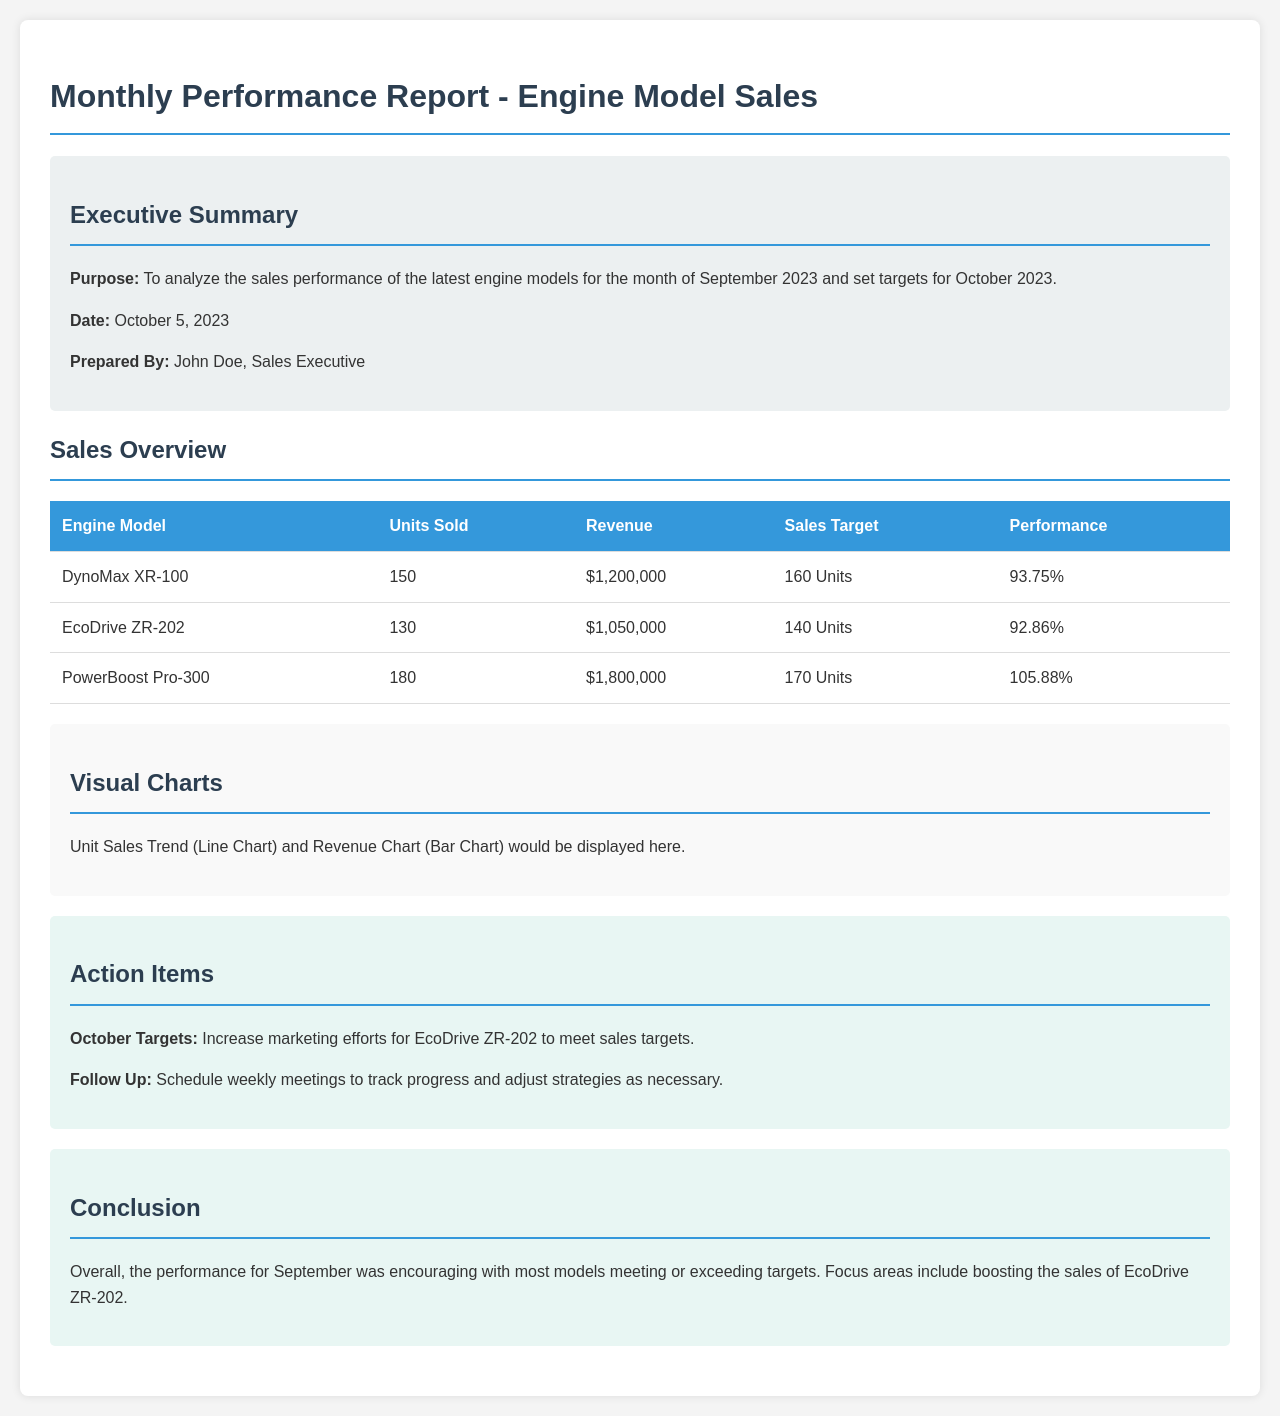What is the date of the report? The date of the report is stated in the executive summary section, showing when it was prepared.
Answer: October 5, 2023 How many units of PowerBoost Pro-300 were sold? The table provides direct information on the units sold for each engine model, specifically for PowerBoost Pro-300.
Answer: 180 What is the sales target for EcoDrive ZR-202? The sales target for EcoDrive ZR-202 is listed in the table alongside its relevant performance metrics.
Answer: 140 Units What percentage performance did DynoMax XR-100 achieve? The performance percentage is given in the table, specifically for DynoMax XR-100.
Answer: 93.75% What action item is proposed for October regarding EcoDrive ZR-202? The document outlines specific actions that should be taken in the action items section, especially pertaining to sales improvement.
Answer: Increase marketing efforts How many models exceeded their sales targets? By analyzing the performance percentages in the table, we can identify which models performed better than their targets.
Answer: 1 In what section is the conclusion located? The conclusion of the report is clearly identified by a titled section, reflecting the overall assessment.
Answer: Conclusion Who prepared the report? The individual's name who prepared the report is mentioned in the executive summary section.
Answer: John Doe What is the revenue generated from EcoDrive ZR-202? The revenue for EcoDrive ZR-202 can be found in the table, next to its respective sales metrics.
Answer: $1,050,000 